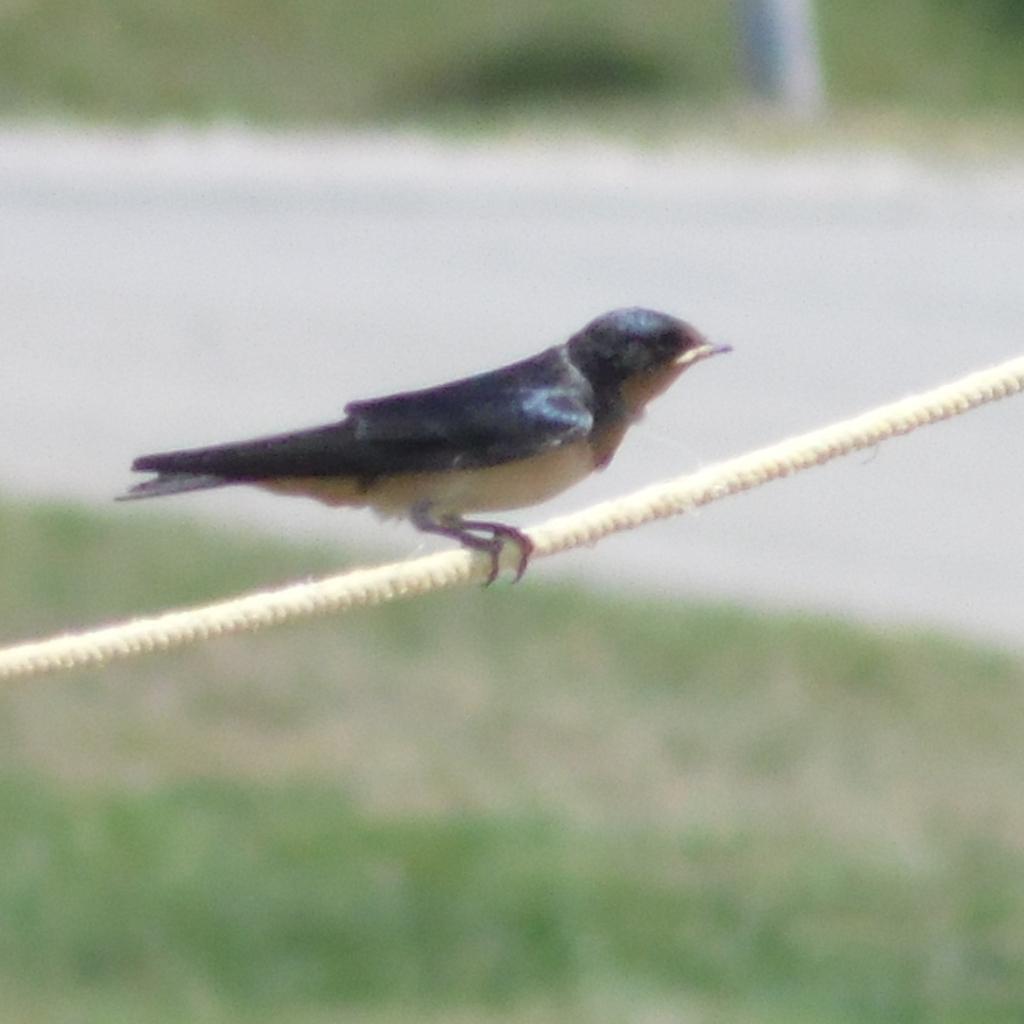In one or two sentences, can you explain what this image depicts? In this image in the center there is one bird on a rope, and at the bottom there is grass and walkway. At the top of the image there is some grass. 